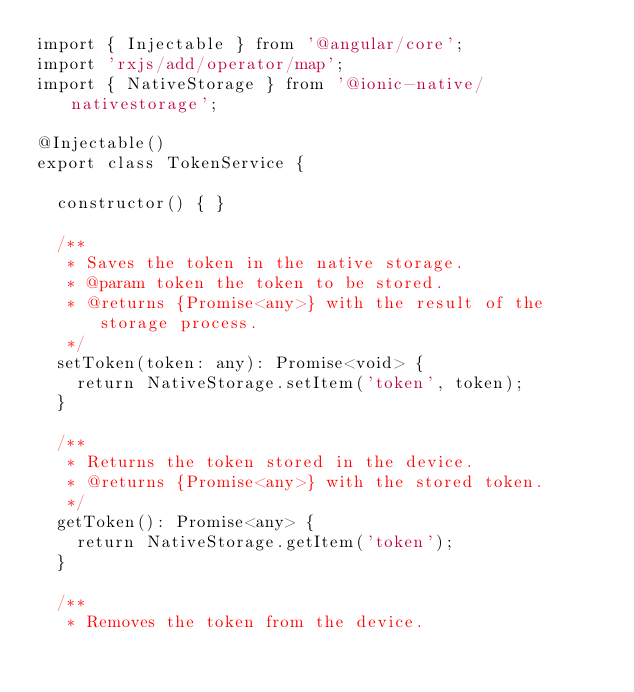<code> <loc_0><loc_0><loc_500><loc_500><_TypeScript_>import { Injectable } from '@angular/core';
import 'rxjs/add/operator/map';
import { NativeStorage } from '@ionic-native/nativestorage';

@Injectable()
export class TokenService {

  constructor() { }

  /**
   * Saves the token in the native storage.
   * @param token the token to be stored.
   * @returns {Promise<any>} with the result of the storage process.
   */
  setToken(token: any): Promise<void> {
    return NativeStorage.setItem('token', token);
  }

  /**
   * Returns the token stored in the device.
   * @returns {Promise<any>} with the stored token.
   */
  getToken(): Promise<any> {
    return NativeStorage.getItem('token');
  }

  /**
   * Removes the token from the device.</code> 